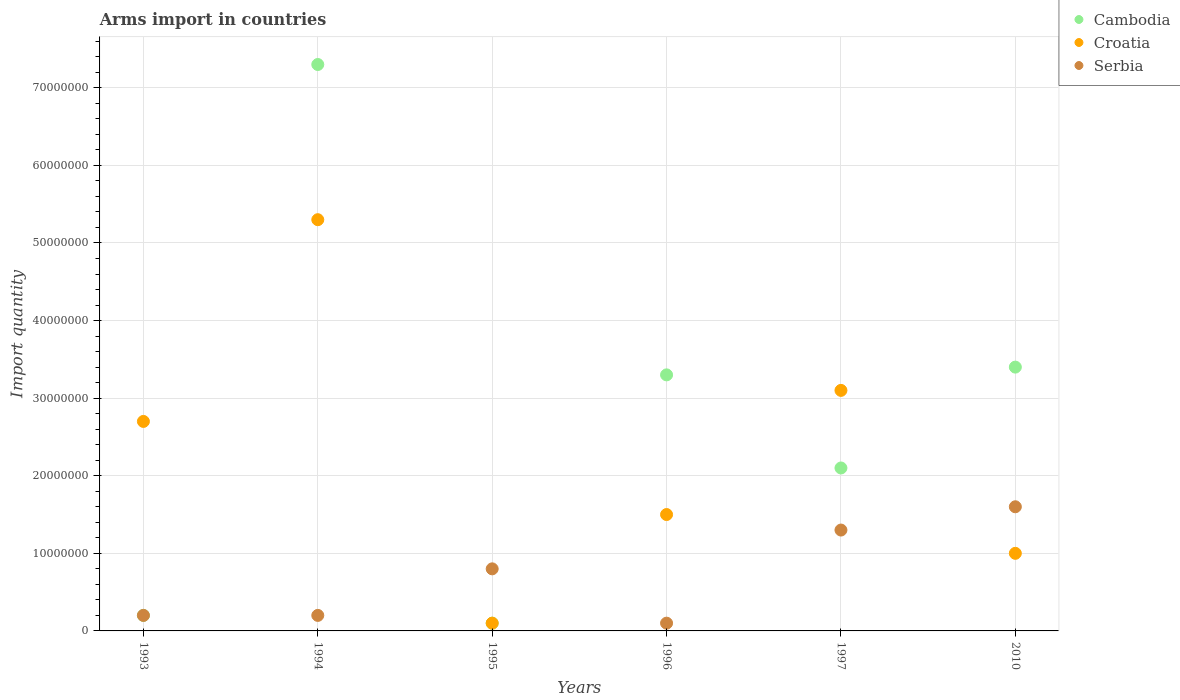Across all years, what is the maximum total arms import in Croatia?
Provide a succinct answer. 5.30e+07. In which year was the total arms import in Serbia maximum?
Keep it short and to the point. 2010. In which year was the total arms import in Cambodia minimum?
Offer a terse response. 1995. What is the total total arms import in Serbia in the graph?
Offer a terse response. 4.20e+07. What is the difference between the total arms import in Serbia in 1994 and that in 1995?
Provide a short and direct response. -6.00e+06. What is the difference between the total arms import in Serbia in 1997 and the total arms import in Croatia in 1996?
Your answer should be compact. -2.00e+06. What is the average total arms import in Serbia per year?
Your response must be concise. 7.00e+06. In the year 1996, what is the difference between the total arms import in Cambodia and total arms import in Croatia?
Offer a very short reply. 1.80e+07. In how many years, is the total arms import in Croatia greater than 54000000?
Give a very brief answer. 0. What is the ratio of the total arms import in Serbia in 1997 to that in 2010?
Provide a short and direct response. 0.81. Is the total arms import in Croatia in 1993 less than that in 1994?
Your answer should be compact. Yes. What is the difference between the highest and the lowest total arms import in Cambodia?
Ensure brevity in your answer.  7.20e+07. Is the total arms import in Cambodia strictly greater than the total arms import in Serbia over the years?
Your response must be concise. No. How many dotlines are there?
Provide a succinct answer. 3. How many years are there in the graph?
Offer a very short reply. 6. What is the difference between two consecutive major ticks on the Y-axis?
Offer a terse response. 1.00e+07. Does the graph contain any zero values?
Your answer should be very brief. No. Does the graph contain grids?
Your response must be concise. Yes. How many legend labels are there?
Make the answer very short. 3. How are the legend labels stacked?
Make the answer very short. Vertical. What is the title of the graph?
Ensure brevity in your answer.  Arms import in countries. Does "Yemen, Rep." appear as one of the legend labels in the graph?
Give a very brief answer. No. What is the label or title of the X-axis?
Ensure brevity in your answer.  Years. What is the label or title of the Y-axis?
Provide a succinct answer. Import quantity. What is the Import quantity of Cambodia in 1993?
Your answer should be very brief. 2.00e+06. What is the Import quantity in Croatia in 1993?
Your answer should be very brief. 2.70e+07. What is the Import quantity of Cambodia in 1994?
Ensure brevity in your answer.  7.30e+07. What is the Import quantity of Croatia in 1994?
Give a very brief answer. 5.30e+07. What is the Import quantity of Cambodia in 1995?
Offer a terse response. 1.00e+06. What is the Import quantity in Croatia in 1995?
Offer a terse response. 1.00e+06. What is the Import quantity in Cambodia in 1996?
Your response must be concise. 3.30e+07. What is the Import quantity in Croatia in 1996?
Your answer should be compact. 1.50e+07. What is the Import quantity of Serbia in 1996?
Keep it short and to the point. 1.00e+06. What is the Import quantity of Cambodia in 1997?
Make the answer very short. 2.10e+07. What is the Import quantity in Croatia in 1997?
Make the answer very short. 3.10e+07. What is the Import quantity in Serbia in 1997?
Give a very brief answer. 1.30e+07. What is the Import quantity in Cambodia in 2010?
Make the answer very short. 3.40e+07. What is the Import quantity of Serbia in 2010?
Your answer should be very brief. 1.60e+07. Across all years, what is the maximum Import quantity in Cambodia?
Offer a terse response. 7.30e+07. Across all years, what is the maximum Import quantity of Croatia?
Make the answer very short. 5.30e+07. Across all years, what is the maximum Import quantity of Serbia?
Your response must be concise. 1.60e+07. What is the total Import quantity of Cambodia in the graph?
Ensure brevity in your answer.  1.64e+08. What is the total Import quantity in Croatia in the graph?
Provide a succinct answer. 1.37e+08. What is the total Import quantity of Serbia in the graph?
Your response must be concise. 4.20e+07. What is the difference between the Import quantity of Cambodia in 1993 and that in 1994?
Keep it short and to the point. -7.10e+07. What is the difference between the Import quantity in Croatia in 1993 and that in 1994?
Give a very brief answer. -2.60e+07. What is the difference between the Import quantity of Croatia in 1993 and that in 1995?
Ensure brevity in your answer.  2.60e+07. What is the difference between the Import quantity in Serbia in 1993 and that in 1995?
Ensure brevity in your answer.  -6.00e+06. What is the difference between the Import quantity of Cambodia in 1993 and that in 1996?
Provide a succinct answer. -3.10e+07. What is the difference between the Import quantity in Croatia in 1993 and that in 1996?
Your answer should be very brief. 1.20e+07. What is the difference between the Import quantity of Cambodia in 1993 and that in 1997?
Give a very brief answer. -1.90e+07. What is the difference between the Import quantity of Serbia in 1993 and that in 1997?
Your answer should be compact. -1.10e+07. What is the difference between the Import quantity of Cambodia in 1993 and that in 2010?
Keep it short and to the point. -3.20e+07. What is the difference between the Import quantity of Croatia in 1993 and that in 2010?
Offer a terse response. 1.70e+07. What is the difference between the Import quantity in Serbia in 1993 and that in 2010?
Ensure brevity in your answer.  -1.40e+07. What is the difference between the Import quantity of Cambodia in 1994 and that in 1995?
Offer a terse response. 7.20e+07. What is the difference between the Import quantity in Croatia in 1994 and that in 1995?
Your response must be concise. 5.20e+07. What is the difference between the Import quantity in Serbia in 1994 and that in 1995?
Offer a very short reply. -6.00e+06. What is the difference between the Import quantity of Cambodia in 1994 and that in 1996?
Make the answer very short. 4.00e+07. What is the difference between the Import quantity of Croatia in 1994 and that in 1996?
Provide a short and direct response. 3.80e+07. What is the difference between the Import quantity of Cambodia in 1994 and that in 1997?
Give a very brief answer. 5.20e+07. What is the difference between the Import quantity in Croatia in 1994 and that in 1997?
Keep it short and to the point. 2.20e+07. What is the difference between the Import quantity in Serbia in 1994 and that in 1997?
Provide a short and direct response. -1.10e+07. What is the difference between the Import quantity in Cambodia in 1994 and that in 2010?
Provide a short and direct response. 3.90e+07. What is the difference between the Import quantity of Croatia in 1994 and that in 2010?
Your response must be concise. 4.30e+07. What is the difference between the Import quantity in Serbia in 1994 and that in 2010?
Offer a very short reply. -1.40e+07. What is the difference between the Import quantity of Cambodia in 1995 and that in 1996?
Offer a very short reply. -3.20e+07. What is the difference between the Import quantity in Croatia in 1995 and that in 1996?
Your answer should be very brief. -1.40e+07. What is the difference between the Import quantity in Serbia in 1995 and that in 1996?
Keep it short and to the point. 7.00e+06. What is the difference between the Import quantity of Cambodia in 1995 and that in 1997?
Offer a terse response. -2.00e+07. What is the difference between the Import quantity of Croatia in 1995 and that in 1997?
Offer a terse response. -3.00e+07. What is the difference between the Import quantity of Serbia in 1995 and that in 1997?
Offer a terse response. -5.00e+06. What is the difference between the Import quantity of Cambodia in 1995 and that in 2010?
Make the answer very short. -3.30e+07. What is the difference between the Import quantity in Croatia in 1995 and that in 2010?
Offer a terse response. -9.00e+06. What is the difference between the Import quantity of Serbia in 1995 and that in 2010?
Offer a terse response. -8.00e+06. What is the difference between the Import quantity in Croatia in 1996 and that in 1997?
Provide a succinct answer. -1.60e+07. What is the difference between the Import quantity of Serbia in 1996 and that in 1997?
Make the answer very short. -1.20e+07. What is the difference between the Import quantity of Serbia in 1996 and that in 2010?
Make the answer very short. -1.50e+07. What is the difference between the Import quantity in Cambodia in 1997 and that in 2010?
Your answer should be very brief. -1.30e+07. What is the difference between the Import quantity in Croatia in 1997 and that in 2010?
Provide a short and direct response. 2.10e+07. What is the difference between the Import quantity of Serbia in 1997 and that in 2010?
Give a very brief answer. -3.00e+06. What is the difference between the Import quantity of Cambodia in 1993 and the Import quantity of Croatia in 1994?
Offer a terse response. -5.10e+07. What is the difference between the Import quantity in Croatia in 1993 and the Import quantity in Serbia in 1994?
Offer a very short reply. 2.50e+07. What is the difference between the Import quantity in Cambodia in 1993 and the Import quantity in Croatia in 1995?
Give a very brief answer. 1.00e+06. What is the difference between the Import quantity in Cambodia in 1993 and the Import quantity in Serbia in 1995?
Give a very brief answer. -6.00e+06. What is the difference between the Import quantity in Croatia in 1993 and the Import quantity in Serbia in 1995?
Provide a short and direct response. 1.90e+07. What is the difference between the Import quantity in Cambodia in 1993 and the Import quantity in Croatia in 1996?
Your response must be concise. -1.30e+07. What is the difference between the Import quantity in Cambodia in 1993 and the Import quantity in Serbia in 1996?
Offer a very short reply. 1.00e+06. What is the difference between the Import quantity in Croatia in 1993 and the Import quantity in Serbia in 1996?
Offer a terse response. 2.60e+07. What is the difference between the Import quantity in Cambodia in 1993 and the Import quantity in Croatia in 1997?
Provide a succinct answer. -2.90e+07. What is the difference between the Import quantity in Cambodia in 1993 and the Import quantity in Serbia in 1997?
Your answer should be very brief. -1.10e+07. What is the difference between the Import quantity in Croatia in 1993 and the Import quantity in Serbia in 1997?
Provide a short and direct response. 1.40e+07. What is the difference between the Import quantity of Cambodia in 1993 and the Import quantity of Croatia in 2010?
Ensure brevity in your answer.  -8.00e+06. What is the difference between the Import quantity in Cambodia in 1993 and the Import quantity in Serbia in 2010?
Offer a very short reply. -1.40e+07. What is the difference between the Import quantity of Croatia in 1993 and the Import quantity of Serbia in 2010?
Your answer should be very brief. 1.10e+07. What is the difference between the Import quantity of Cambodia in 1994 and the Import quantity of Croatia in 1995?
Your answer should be compact. 7.20e+07. What is the difference between the Import quantity of Cambodia in 1994 and the Import quantity of Serbia in 1995?
Give a very brief answer. 6.50e+07. What is the difference between the Import quantity of Croatia in 1994 and the Import quantity of Serbia in 1995?
Provide a succinct answer. 4.50e+07. What is the difference between the Import quantity of Cambodia in 1994 and the Import quantity of Croatia in 1996?
Provide a short and direct response. 5.80e+07. What is the difference between the Import quantity in Cambodia in 1994 and the Import quantity in Serbia in 1996?
Offer a terse response. 7.20e+07. What is the difference between the Import quantity in Croatia in 1994 and the Import quantity in Serbia in 1996?
Your response must be concise. 5.20e+07. What is the difference between the Import quantity in Cambodia in 1994 and the Import quantity in Croatia in 1997?
Give a very brief answer. 4.20e+07. What is the difference between the Import quantity in Cambodia in 1994 and the Import quantity in Serbia in 1997?
Offer a very short reply. 6.00e+07. What is the difference between the Import quantity of Croatia in 1994 and the Import quantity of Serbia in 1997?
Keep it short and to the point. 4.00e+07. What is the difference between the Import quantity in Cambodia in 1994 and the Import quantity in Croatia in 2010?
Keep it short and to the point. 6.30e+07. What is the difference between the Import quantity of Cambodia in 1994 and the Import quantity of Serbia in 2010?
Give a very brief answer. 5.70e+07. What is the difference between the Import quantity of Croatia in 1994 and the Import quantity of Serbia in 2010?
Your answer should be very brief. 3.70e+07. What is the difference between the Import quantity in Cambodia in 1995 and the Import quantity in Croatia in 1996?
Ensure brevity in your answer.  -1.40e+07. What is the difference between the Import quantity in Cambodia in 1995 and the Import quantity in Serbia in 1996?
Keep it short and to the point. 0. What is the difference between the Import quantity in Croatia in 1995 and the Import quantity in Serbia in 1996?
Make the answer very short. 0. What is the difference between the Import quantity in Cambodia in 1995 and the Import quantity in Croatia in 1997?
Provide a succinct answer. -3.00e+07. What is the difference between the Import quantity in Cambodia in 1995 and the Import quantity in Serbia in 1997?
Make the answer very short. -1.20e+07. What is the difference between the Import quantity of Croatia in 1995 and the Import quantity of Serbia in 1997?
Make the answer very short. -1.20e+07. What is the difference between the Import quantity of Cambodia in 1995 and the Import quantity of Croatia in 2010?
Keep it short and to the point. -9.00e+06. What is the difference between the Import quantity of Cambodia in 1995 and the Import quantity of Serbia in 2010?
Provide a short and direct response. -1.50e+07. What is the difference between the Import quantity in Croatia in 1995 and the Import quantity in Serbia in 2010?
Give a very brief answer. -1.50e+07. What is the difference between the Import quantity in Cambodia in 1996 and the Import quantity in Croatia in 1997?
Your answer should be compact. 2.00e+06. What is the difference between the Import quantity of Croatia in 1996 and the Import quantity of Serbia in 1997?
Ensure brevity in your answer.  2.00e+06. What is the difference between the Import quantity in Cambodia in 1996 and the Import quantity in Croatia in 2010?
Your answer should be very brief. 2.30e+07. What is the difference between the Import quantity of Cambodia in 1996 and the Import quantity of Serbia in 2010?
Make the answer very short. 1.70e+07. What is the difference between the Import quantity in Cambodia in 1997 and the Import quantity in Croatia in 2010?
Your response must be concise. 1.10e+07. What is the difference between the Import quantity in Cambodia in 1997 and the Import quantity in Serbia in 2010?
Offer a very short reply. 5.00e+06. What is the difference between the Import quantity in Croatia in 1997 and the Import quantity in Serbia in 2010?
Provide a short and direct response. 1.50e+07. What is the average Import quantity of Cambodia per year?
Ensure brevity in your answer.  2.73e+07. What is the average Import quantity in Croatia per year?
Provide a short and direct response. 2.28e+07. What is the average Import quantity in Serbia per year?
Your answer should be compact. 7.00e+06. In the year 1993, what is the difference between the Import quantity of Cambodia and Import quantity of Croatia?
Make the answer very short. -2.50e+07. In the year 1993, what is the difference between the Import quantity in Croatia and Import quantity in Serbia?
Your answer should be very brief. 2.50e+07. In the year 1994, what is the difference between the Import quantity in Cambodia and Import quantity in Serbia?
Give a very brief answer. 7.10e+07. In the year 1994, what is the difference between the Import quantity of Croatia and Import quantity of Serbia?
Provide a succinct answer. 5.10e+07. In the year 1995, what is the difference between the Import quantity in Cambodia and Import quantity in Croatia?
Offer a terse response. 0. In the year 1995, what is the difference between the Import quantity in Cambodia and Import quantity in Serbia?
Ensure brevity in your answer.  -7.00e+06. In the year 1995, what is the difference between the Import quantity of Croatia and Import quantity of Serbia?
Offer a terse response. -7.00e+06. In the year 1996, what is the difference between the Import quantity of Cambodia and Import quantity of Croatia?
Your answer should be very brief. 1.80e+07. In the year 1996, what is the difference between the Import quantity of Cambodia and Import quantity of Serbia?
Your answer should be very brief. 3.20e+07. In the year 1996, what is the difference between the Import quantity of Croatia and Import quantity of Serbia?
Your answer should be very brief. 1.40e+07. In the year 1997, what is the difference between the Import quantity of Cambodia and Import quantity of Croatia?
Provide a short and direct response. -1.00e+07. In the year 1997, what is the difference between the Import quantity of Croatia and Import quantity of Serbia?
Your answer should be very brief. 1.80e+07. In the year 2010, what is the difference between the Import quantity of Cambodia and Import quantity of Croatia?
Give a very brief answer. 2.40e+07. In the year 2010, what is the difference between the Import quantity in Cambodia and Import quantity in Serbia?
Your answer should be very brief. 1.80e+07. In the year 2010, what is the difference between the Import quantity of Croatia and Import quantity of Serbia?
Your response must be concise. -6.00e+06. What is the ratio of the Import quantity of Cambodia in 1993 to that in 1994?
Keep it short and to the point. 0.03. What is the ratio of the Import quantity in Croatia in 1993 to that in 1994?
Your answer should be very brief. 0.51. What is the ratio of the Import quantity in Cambodia in 1993 to that in 1995?
Provide a succinct answer. 2. What is the ratio of the Import quantity in Serbia in 1993 to that in 1995?
Your response must be concise. 0.25. What is the ratio of the Import quantity in Cambodia in 1993 to that in 1996?
Your answer should be compact. 0.06. What is the ratio of the Import quantity of Croatia in 1993 to that in 1996?
Your answer should be compact. 1.8. What is the ratio of the Import quantity of Serbia in 1993 to that in 1996?
Your answer should be compact. 2. What is the ratio of the Import quantity in Cambodia in 1993 to that in 1997?
Give a very brief answer. 0.1. What is the ratio of the Import quantity of Croatia in 1993 to that in 1997?
Offer a very short reply. 0.87. What is the ratio of the Import quantity in Serbia in 1993 to that in 1997?
Your answer should be very brief. 0.15. What is the ratio of the Import quantity in Cambodia in 1993 to that in 2010?
Make the answer very short. 0.06. What is the ratio of the Import quantity in Serbia in 1993 to that in 2010?
Give a very brief answer. 0.12. What is the ratio of the Import quantity of Cambodia in 1994 to that in 1995?
Ensure brevity in your answer.  73. What is the ratio of the Import quantity in Croatia in 1994 to that in 1995?
Provide a succinct answer. 53. What is the ratio of the Import quantity of Serbia in 1994 to that in 1995?
Make the answer very short. 0.25. What is the ratio of the Import quantity in Cambodia in 1994 to that in 1996?
Provide a short and direct response. 2.21. What is the ratio of the Import quantity in Croatia in 1994 to that in 1996?
Give a very brief answer. 3.53. What is the ratio of the Import quantity in Serbia in 1994 to that in 1996?
Make the answer very short. 2. What is the ratio of the Import quantity of Cambodia in 1994 to that in 1997?
Make the answer very short. 3.48. What is the ratio of the Import quantity in Croatia in 1994 to that in 1997?
Make the answer very short. 1.71. What is the ratio of the Import quantity in Serbia in 1994 to that in 1997?
Your answer should be compact. 0.15. What is the ratio of the Import quantity of Cambodia in 1994 to that in 2010?
Provide a short and direct response. 2.15. What is the ratio of the Import quantity of Croatia in 1994 to that in 2010?
Offer a terse response. 5.3. What is the ratio of the Import quantity of Serbia in 1994 to that in 2010?
Provide a short and direct response. 0.12. What is the ratio of the Import quantity of Cambodia in 1995 to that in 1996?
Offer a terse response. 0.03. What is the ratio of the Import quantity of Croatia in 1995 to that in 1996?
Your response must be concise. 0.07. What is the ratio of the Import quantity in Serbia in 1995 to that in 1996?
Ensure brevity in your answer.  8. What is the ratio of the Import quantity in Cambodia in 1995 to that in 1997?
Offer a very short reply. 0.05. What is the ratio of the Import quantity of Croatia in 1995 to that in 1997?
Provide a succinct answer. 0.03. What is the ratio of the Import quantity in Serbia in 1995 to that in 1997?
Your answer should be very brief. 0.62. What is the ratio of the Import quantity in Cambodia in 1995 to that in 2010?
Give a very brief answer. 0.03. What is the ratio of the Import quantity in Cambodia in 1996 to that in 1997?
Offer a terse response. 1.57. What is the ratio of the Import quantity in Croatia in 1996 to that in 1997?
Ensure brevity in your answer.  0.48. What is the ratio of the Import quantity of Serbia in 1996 to that in 1997?
Make the answer very short. 0.08. What is the ratio of the Import quantity in Cambodia in 1996 to that in 2010?
Give a very brief answer. 0.97. What is the ratio of the Import quantity in Croatia in 1996 to that in 2010?
Keep it short and to the point. 1.5. What is the ratio of the Import quantity of Serbia in 1996 to that in 2010?
Provide a succinct answer. 0.06. What is the ratio of the Import quantity in Cambodia in 1997 to that in 2010?
Make the answer very short. 0.62. What is the ratio of the Import quantity of Serbia in 1997 to that in 2010?
Keep it short and to the point. 0.81. What is the difference between the highest and the second highest Import quantity in Cambodia?
Offer a very short reply. 3.90e+07. What is the difference between the highest and the second highest Import quantity of Croatia?
Offer a terse response. 2.20e+07. What is the difference between the highest and the lowest Import quantity of Cambodia?
Provide a succinct answer. 7.20e+07. What is the difference between the highest and the lowest Import quantity in Croatia?
Offer a terse response. 5.20e+07. What is the difference between the highest and the lowest Import quantity of Serbia?
Keep it short and to the point. 1.50e+07. 